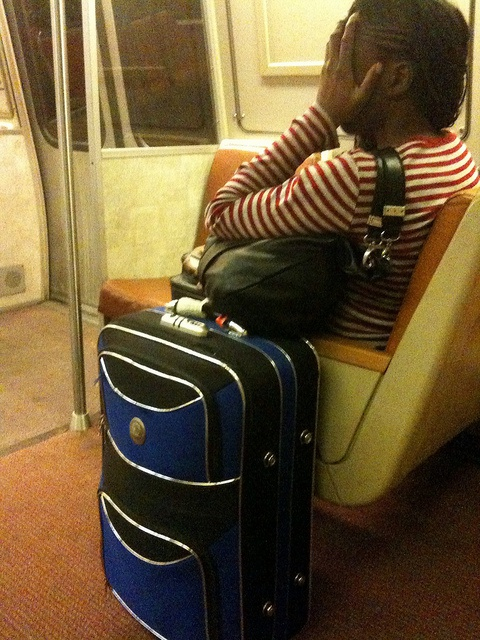Describe the objects in this image and their specific colors. I can see suitcase in tan, black, navy, darkgreen, and ivory tones, people in tan, black, and maroon tones, bench in tan, olive, maroon, and black tones, and handbag in tan, black, darkgreen, and olive tones in this image. 